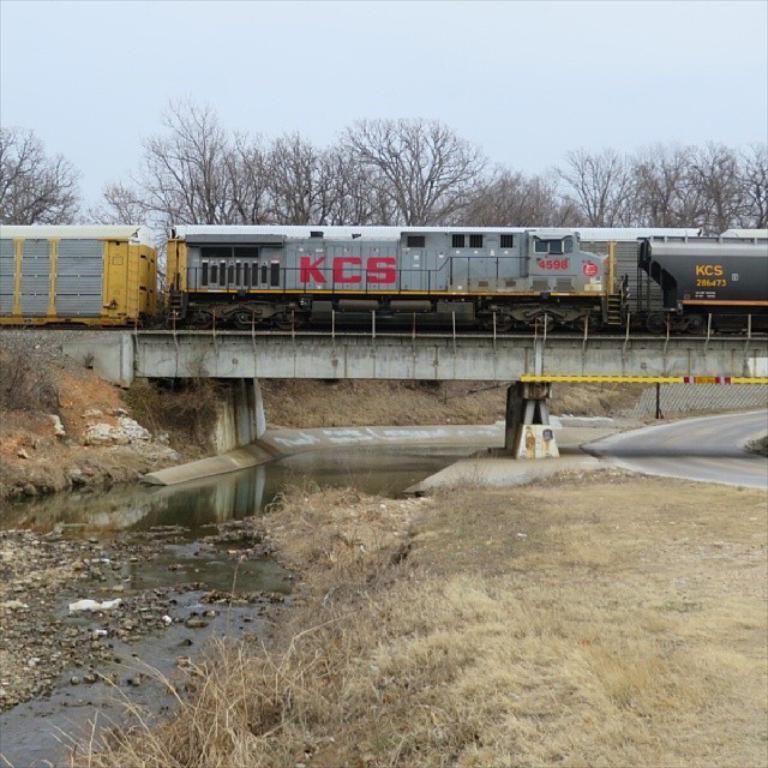Can you describe this image briefly? There is a train on the track which is on the bridge and there are water in the left corner and there are trees in the background. 